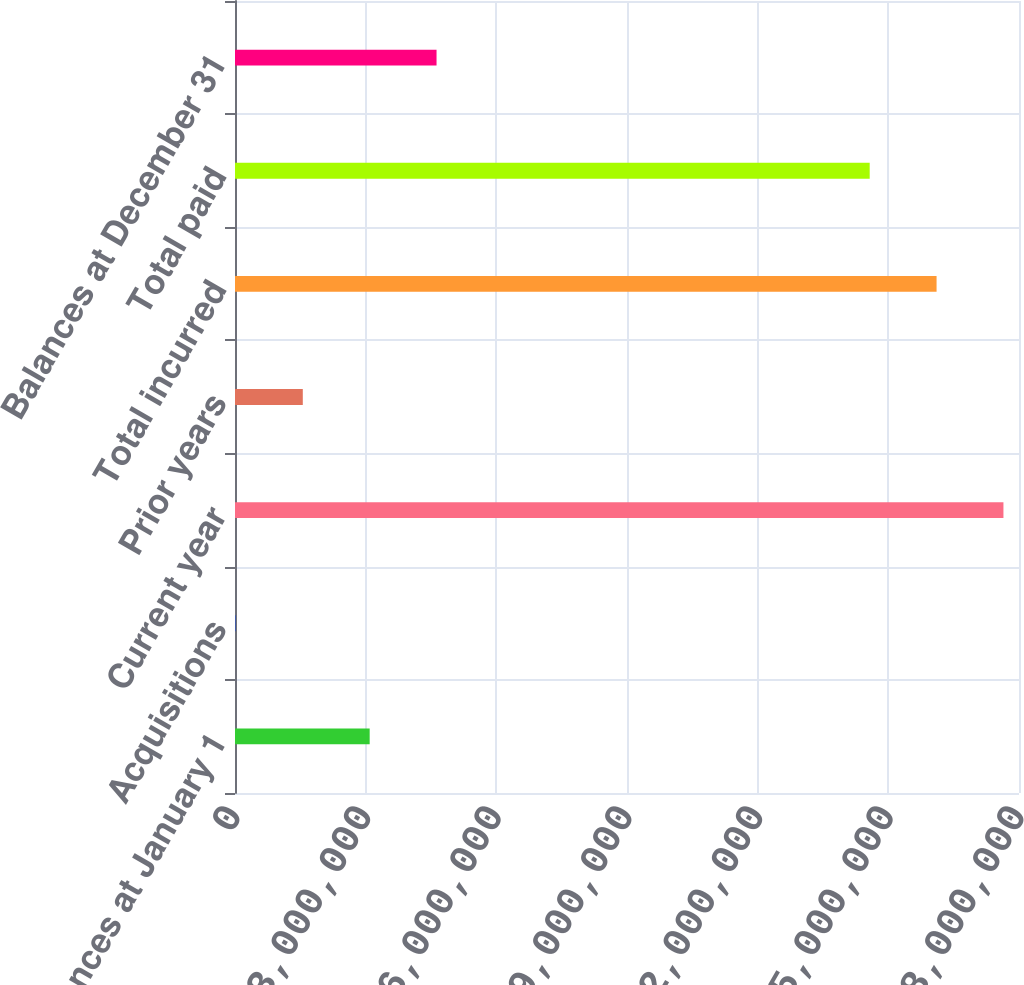Convert chart. <chart><loc_0><loc_0><loc_500><loc_500><bar_chart><fcel>Balances at January 1<fcel>Acquisitions<fcel>Current year<fcel>Prior years<fcel>Total incurred<fcel>Total paid<fcel>Balances at December 31<nl><fcel>3.09193e+06<fcel>21198<fcel>1.76428e+07<fcel>1.55656e+06<fcel>1.61074e+07<fcel>1.4572e+07<fcel>4.6273e+06<nl></chart> 